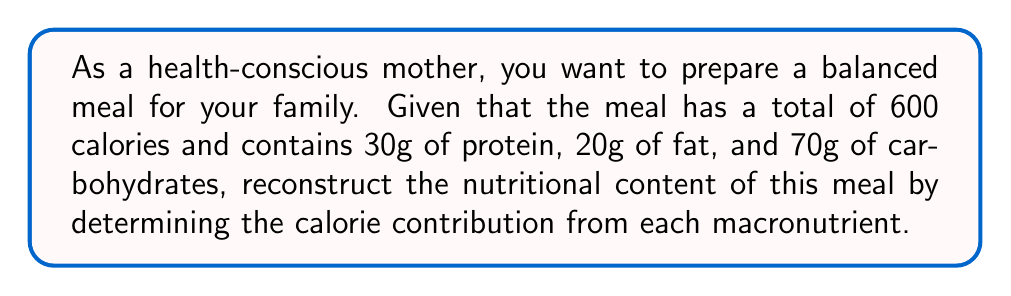Give your solution to this math problem. Let's approach this step-by-step:

1) First, recall the calorie content of each macronutrient:
   - Protein: 4 calories per gram
   - Carbohydrates: 4 calories per gram
   - Fat: 9 calories per gram

2) Calculate the calories from protein:
   $$ \text{Protein calories} = 30g \times 4\text{ cal/g} = 120\text{ calories} $$

3) Calculate the calories from carbohydrates:
   $$ \text{Carbohydrate calories} = 70g \times 4\text{ cal/g} = 280\text{ calories} $$

4) Calculate the calories from fat:
   $$ \text{Fat calories} = 20g \times 9\text{ cal/g} = 180\text{ calories} $$

5) Verify that the sum of these calories equals the total:
   $$ 120 + 280 + 180 = 580\text{ calories} $$

6) Calculate the percentage contribution of each macronutrient:
   $$ \text{Protein} \%: \frac{120}{600} \times 100\% = 20\% $$
   $$ \text{Carbohydrates} \%: \frac{280}{600} \times 100\% = 46.67\% $$
   $$ \text{Fat} \%: \frac{180}{600} \times 100\% = 30\% $$

Thus, we have reconstructed the nutritional content of the meal in terms of calorie contribution from each macronutrient.
Answer: Protein: 120 cal (20%), Carbohydrates: 280 cal (46.67%), Fat: 180 cal (30%) 